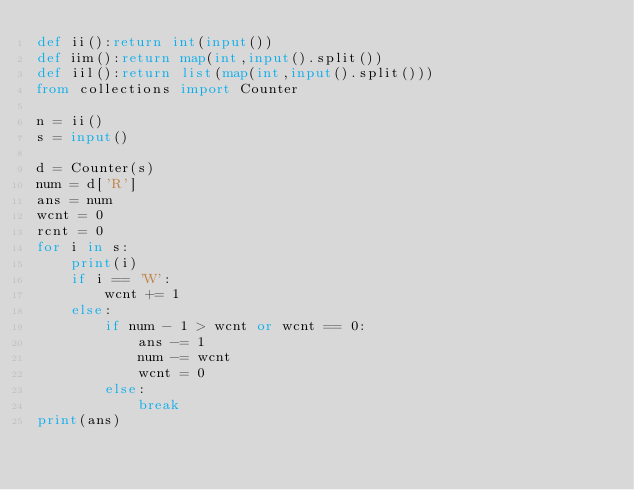Convert code to text. <code><loc_0><loc_0><loc_500><loc_500><_Python_>def ii():return int(input())
def iim():return map(int,input().split())
def iil():return list(map(int,input().split()))
from collections import Counter

n = ii()
s = input()

d = Counter(s)
num = d['R']
ans = num
wcnt = 0
rcnt = 0
for i in s:
    print(i)
    if i == 'W':
        wcnt += 1
    else:
        if num - 1 > wcnt or wcnt == 0:
            ans -= 1
            num -= wcnt
            wcnt = 0
        else:
            break
print(ans)
</code> 